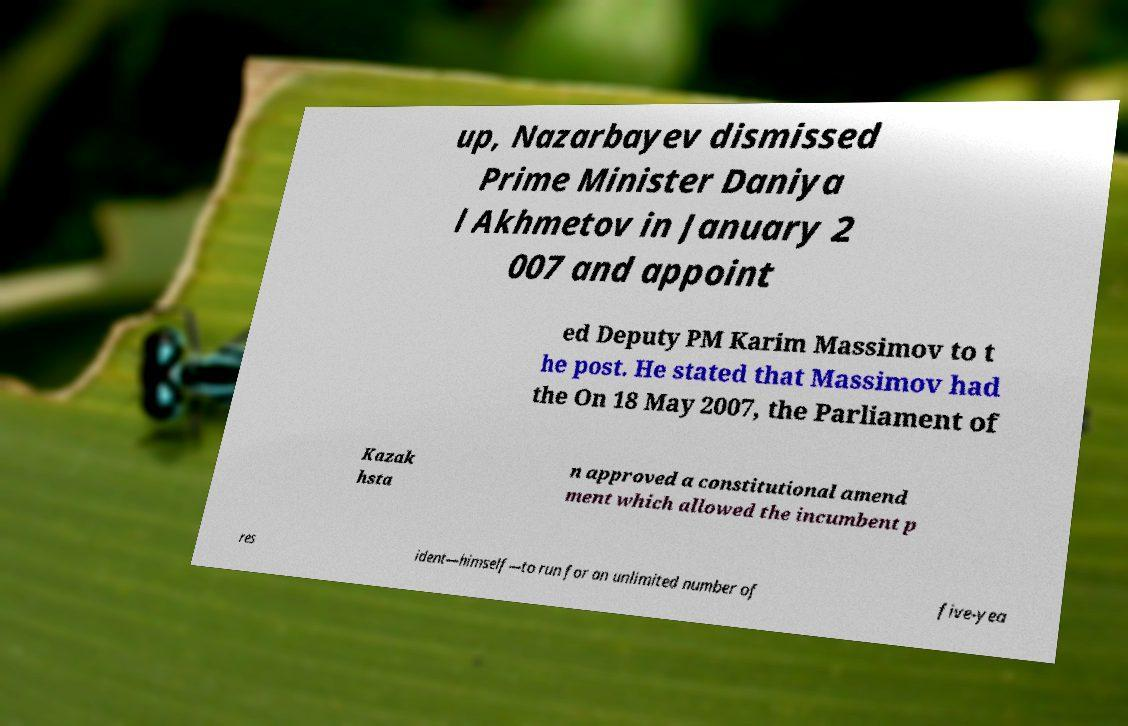Could you assist in decoding the text presented in this image and type it out clearly? up, Nazarbayev dismissed Prime Minister Daniya l Akhmetov in January 2 007 and appoint ed Deputy PM Karim Massimov to t he post. He stated that Massimov had the On 18 May 2007, the Parliament of Kazak hsta n approved a constitutional amend ment which allowed the incumbent p res ident—himself—to run for an unlimited number of five-yea 